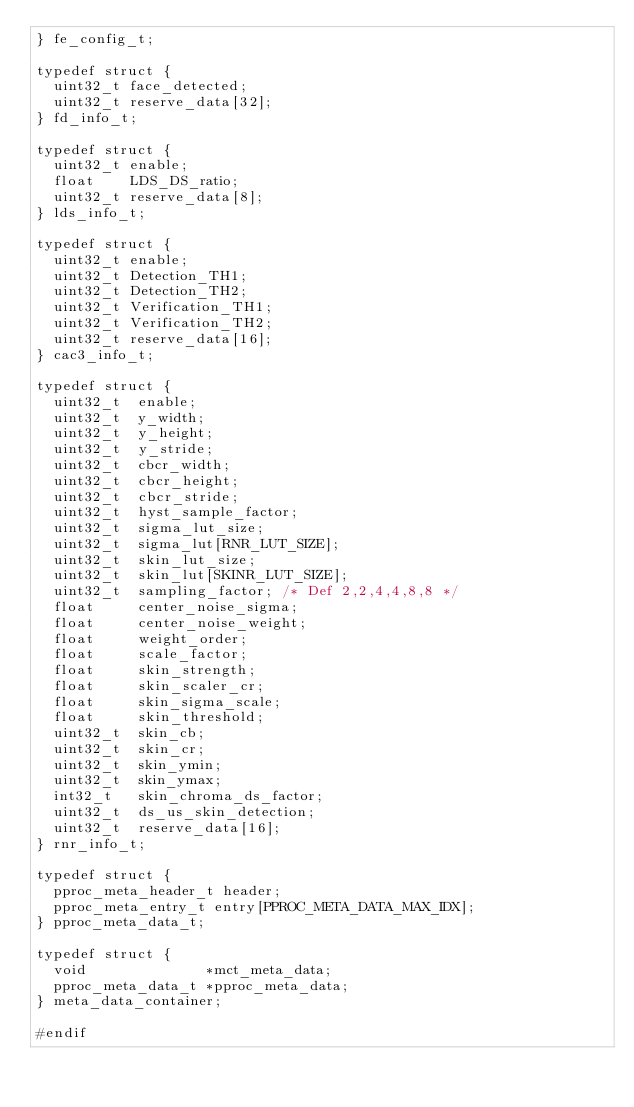Convert code to text. <code><loc_0><loc_0><loc_500><loc_500><_C_>} fe_config_t;

typedef struct {
  uint32_t face_detected;
  uint32_t reserve_data[32];
} fd_info_t;

typedef struct {
  uint32_t enable;
  float    LDS_DS_ratio;
  uint32_t reserve_data[8];
} lds_info_t;

typedef struct {
  uint32_t enable;
  uint32_t Detection_TH1;
  uint32_t Detection_TH2;
  uint32_t Verification_TH1;
  uint32_t Verification_TH2;
  uint32_t reserve_data[16];
} cac3_info_t;

typedef struct {
  uint32_t  enable;
  uint32_t  y_width;
  uint32_t  y_height;
  uint32_t  y_stride;
  uint32_t  cbcr_width;
  uint32_t  cbcr_height;
  uint32_t  cbcr_stride;
  uint32_t  hyst_sample_factor;
  uint32_t  sigma_lut_size;
  uint32_t  sigma_lut[RNR_LUT_SIZE];
  uint32_t  skin_lut_size;
  uint32_t  skin_lut[SKINR_LUT_SIZE];
  uint32_t  sampling_factor; /* Def 2,2,4,4,8,8 */
  float     center_noise_sigma;
  float     center_noise_weight;
  float     weight_order;
  float     scale_factor;
  float     skin_strength;
  float     skin_scaler_cr;
  float     skin_sigma_scale;
  float     skin_threshold;
  uint32_t  skin_cb;
  uint32_t  skin_cr;
  uint32_t  skin_ymin;
  uint32_t  skin_ymax;
  int32_t   skin_chroma_ds_factor;
  uint32_t  ds_us_skin_detection;
  uint32_t  reserve_data[16];
} rnr_info_t;

typedef struct {
  pproc_meta_header_t header;
  pproc_meta_entry_t entry[PPROC_META_DATA_MAX_IDX];
} pproc_meta_data_t;

typedef struct {
  void              *mct_meta_data;
  pproc_meta_data_t *pproc_meta_data;
} meta_data_container;

#endif
</code> 